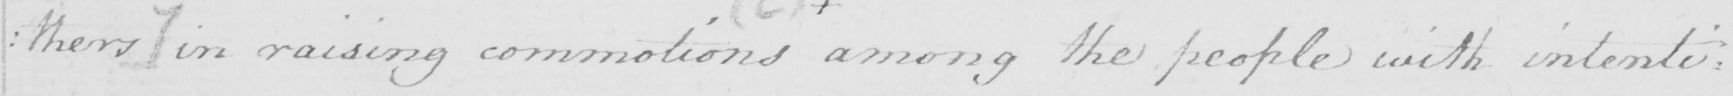What is written in this line of handwriting? : thers ]  in raising commotions among the people with intenti= 